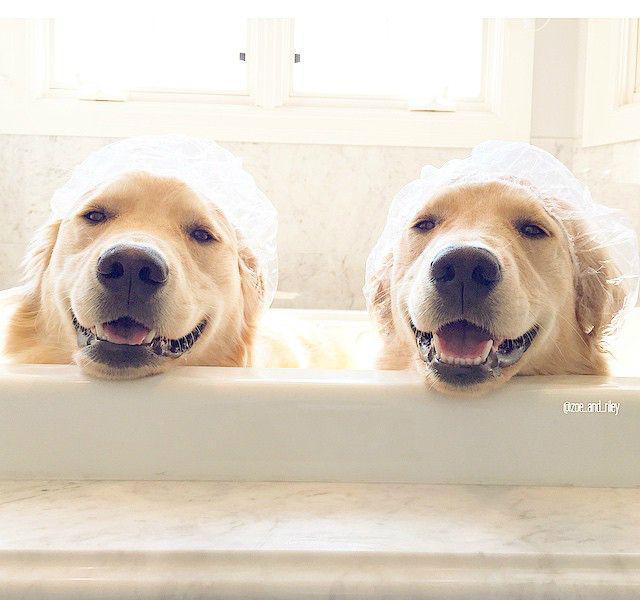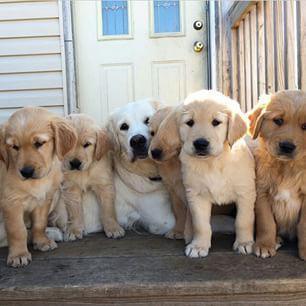The first image is the image on the left, the second image is the image on the right. Analyze the images presented: Is the assertion "there are exactly three animals in the image on the left" valid? Answer yes or no. No. The first image is the image on the left, the second image is the image on the right. Considering the images on both sides, is "The left image shows a total of 3 dogs" valid? Answer yes or no. No. 